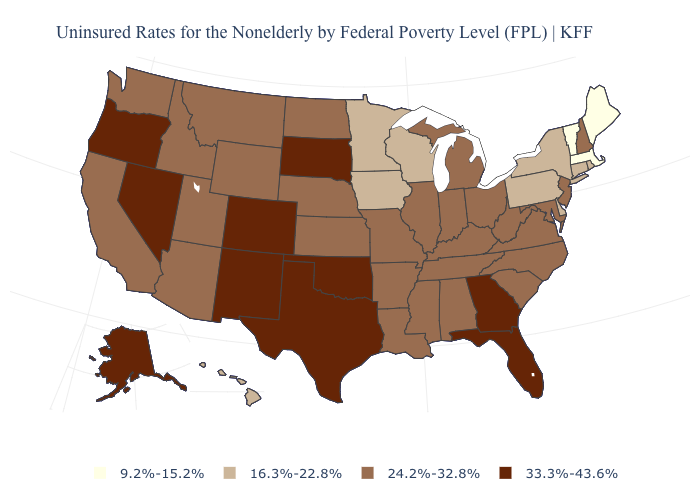Does Alaska have the highest value in the USA?
Give a very brief answer. Yes. What is the value of New Mexico?
Give a very brief answer. 33.3%-43.6%. Which states have the highest value in the USA?
Write a very short answer. Alaska, Colorado, Florida, Georgia, Nevada, New Mexico, Oklahoma, Oregon, South Dakota, Texas. What is the value of Texas?
Short answer required. 33.3%-43.6%. Which states hav the highest value in the MidWest?
Keep it brief. South Dakota. Name the states that have a value in the range 9.2%-15.2%?
Answer briefly. Maine, Massachusetts, Vermont. Which states have the lowest value in the USA?
Concise answer only. Maine, Massachusetts, Vermont. Name the states that have a value in the range 33.3%-43.6%?
Quick response, please. Alaska, Colorado, Florida, Georgia, Nevada, New Mexico, Oklahoma, Oregon, South Dakota, Texas. What is the value of Ohio?
Be succinct. 24.2%-32.8%. Does the first symbol in the legend represent the smallest category?
Quick response, please. Yes. What is the highest value in states that border Delaware?
Write a very short answer. 24.2%-32.8%. Does New Hampshire have a lower value than West Virginia?
Give a very brief answer. No. Does the first symbol in the legend represent the smallest category?
Concise answer only. Yes. Name the states that have a value in the range 33.3%-43.6%?
Write a very short answer. Alaska, Colorado, Florida, Georgia, Nevada, New Mexico, Oklahoma, Oregon, South Dakota, Texas. Which states have the highest value in the USA?
Answer briefly. Alaska, Colorado, Florida, Georgia, Nevada, New Mexico, Oklahoma, Oregon, South Dakota, Texas. 